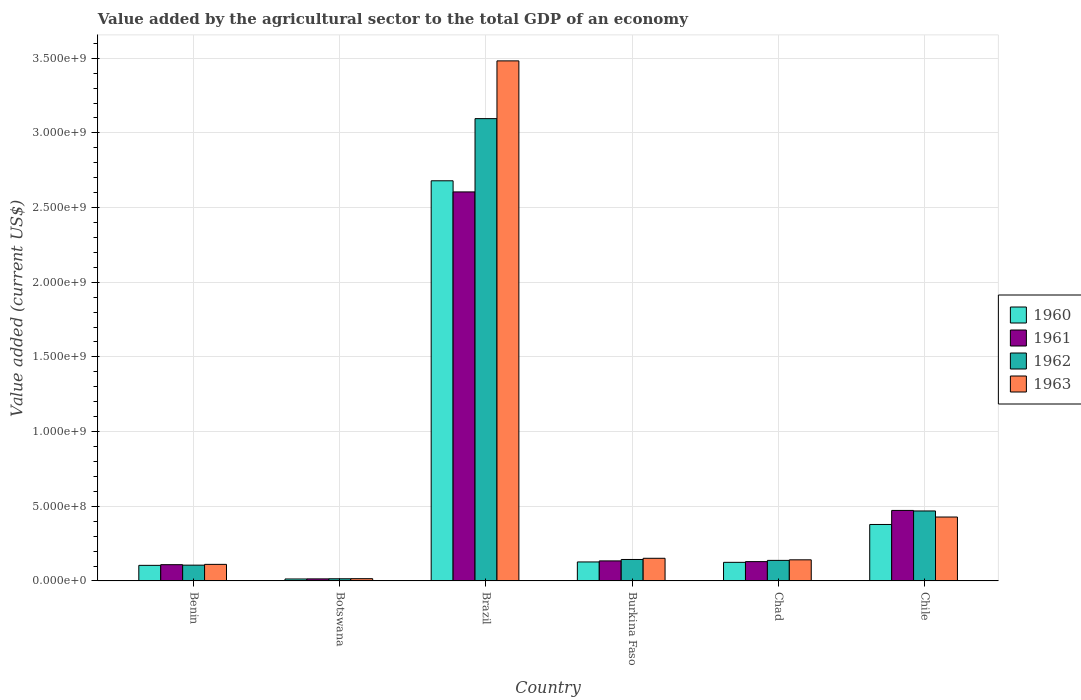How many groups of bars are there?
Keep it short and to the point. 6. How many bars are there on the 6th tick from the left?
Your response must be concise. 4. How many bars are there on the 1st tick from the right?
Your answer should be compact. 4. What is the label of the 1st group of bars from the left?
Your response must be concise. Benin. What is the value added by the agricultural sector to the total GDP in 1960 in Brazil?
Your response must be concise. 2.68e+09. Across all countries, what is the maximum value added by the agricultural sector to the total GDP in 1962?
Provide a succinct answer. 3.10e+09. Across all countries, what is the minimum value added by the agricultural sector to the total GDP in 1963?
Offer a terse response. 1.51e+07. In which country was the value added by the agricultural sector to the total GDP in 1961 maximum?
Give a very brief answer. Brazil. In which country was the value added by the agricultural sector to the total GDP in 1962 minimum?
Offer a very short reply. Botswana. What is the total value added by the agricultural sector to the total GDP in 1963 in the graph?
Keep it short and to the point. 4.33e+09. What is the difference between the value added by the agricultural sector to the total GDP in 1960 in Botswana and that in Chad?
Provide a succinct answer. -1.11e+08. What is the difference between the value added by the agricultural sector to the total GDP in 1961 in Benin and the value added by the agricultural sector to the total GDP in 1960 in Chad?
Offer a very short reply. -1.57e+07. What is the average value added by the agricultural sector to the total GDP in 1960 per country?
Your answer should be compact. 5.71e+08. What is the difference between the value added by the agricultural sector to the total GDP of/in 1960 and value added by the agricultural sector to the total GDP of/in 1962 in Burkina Faso?
Your response must be concise. -1.65e+07. In how many countries, is the value added by the agricultural sector to the total GDP in 1960 greater than 2100000000 US$?
Keep it short and to the point. 1. What is the ratio of the value added by the agricultural sector to the total GDP in 1960 in Benin to that in Botswana?
Make the answer very short. 7.94. Is the difference between the value added by the agricultural sector to the total GDP in 1960 in Botswana and Brazil greater than the difference between the value added by the agricultural sector to the total GDP in 1962 in Botswana and Brazil?
Keep it short and to the point. Yes. What is the difference between the highest and the second highest value added by the agricultural sector to the total GDP in 1960?
Offer a very short reply. -2.30e+09. What is the difference between the highest and the lowest value added by the agricultural sector to the total GDP in 1961?
Keep it short and to the point. 2.59e+09. In how many countries, is the value added by the agricultural sector to the total GDP in 1961 greater than the average value added by the agricultural sector to the total GDP in 1961 taken over all countries?
Your response must be concise. 1. Is it the case that in every country, the sum of the value added by the agricultural sector to the total GDP in 1961 and value added by the agricultural sector to the total GDP in 1960 is greater than the sum of value added by the agricultural sector to the total GDP in 1963 and value added by the agricultural sector to the total GDP in 1962?
Offer a terse response. No. What does the 3rd bar from the left in Chad represents?
Your response must be concise. 1962. Is it the case that in every country, the sum of the value added by the agricultural sector to the total GDP in 1962 and value added by the agricultural sector to the total GDP in 1960 is greater than the value added by the agricultural sector to the total GDP in 1961?
Keep it short and to the point. Yes. How many bars are there?
Make the answer very short. 24. Are all the bars in the graph horizontal?
Provide a succinct answer. No. How many countries are there in the graph?
Provide a succinct answer. 6. Are the values on the major ticks of Y-axis written in scientific E-notation?
Provide a short and direct response. Yes. Does the graph contain grids?
Ensure brevity in your answer.  Yes. How are the legend labels stacked?
Offer a very short reply. Vertical. What is the title of the graph?
Your answer should be compact. Value added by the agricultural sector to the total GDP of an economy. What is the label or title of the X-axis?
Your answer should be compact. Country. What is the label or title of the Y-axis?
Your response must be concise. Value added (current US$). What is the Value added (current US$) in 1960 in Benin?
Provide a succinct answer. 1.04e+08. What is the Value added (current US$) of 1961 in Benin?
Your response must be concise. 1.09e+08. What is the Value added (current US$) of 1962 in Benin?
Offer a very short reply. 1.06e+08. What is the Value added (current US$) in 1963 in Benin?
Provide a succinct answer. 1.11e+08. What is the Value added (current US$) in 1960 in Botswana?
Ensure brevity in your answer.  1.31e+07. What is the Value added (current US$) of 1961 in Botswana?
Your response must be concise. 1.38e+07. What is the Value added (current US$) of 1962 in Botswana?
Make the answer very short. 1.45e+07. What is the Value added (current US$) of 1963 in Botswana?
Make the answer very short. 1.51e+07. What is the Value added (current US$) of 1960 in Brazil?
Your answer should be very brief. 2.68e+09. What is the Value added (current US$) in 1961 in Brazil?
Make the answer very short. 2.60e+09. What is the Value added (current US$) in 1962 in Brazil?
Your response must be concise. 3.10e+09. What is the Value added (current US$) of 1963 in Brazil?
Offer a terse response. 3.48e+09. What is the Value added (current US$) in 1960 in Burkina Faso?
Ensure brevity in your answer.  1.27e+08. What is the Value added (current US$) of 1961 in Burkina Faso?
Give a very brief answer. 1.34e+08. What is the Value added (current US$) of 1962 in Burkina Faso?
Ensure brevity in your answer.  1.44e+08. What is the Value added (current US$) of 1963 in Burkina Faso?
Give a very brief answer. 1.52e+08. What is the Value added (current US$) in 1960 in Chad?
Make the answer very short. 1.25e+08. What is the Value added (current US$) in 1961 in Chad?
Provide a succinct answer. 1.29e+08. What is the Value added (current US$) in 1962 in Chad?
Ensure brevity in your answer.  1.38e+08. What is the Value added (current US$) of 1963 in Chad?
Your answer should be compact. 1.41e+08. What is the Value added (current US$) of 1960 in Chile?
Give a very brief answer. 3.78e+08. What is the Value added (current US$) in 1961 in Chile?
Offer a terse response. 4.72e+08. What is the Value added (current US$) of 1962 in Chile?
Make the answer very short. 4.69e+08. What is the Value added (current US$) in 1963 in Chile?
Your answer should be very brief. 4.28e+08. Across all countries, what is the maximum Value added (current US$) in 1960?
Give a very brief answer. 2.68e+09. Across all countries, what is the maximum Value added (current US$) in 1961?
Make the answer very short. 2.60e+09. Across all countries, what is the maximum Value added (current US$) in 1962?
Provide a short and direct response. 3.10e+09. Across all countries, what is the maximum Value added (current US$) in 1963?
Your answer should be compact. 3.48e+09. Across all countries, what is the minimum Value added (current US$) in 1960?
Make the answer very short. 1.31e+07. Across all countries, what is the minimum Value added (current US$) in 1961?
Keep it short and to the point. 1.38e+07. Across all countries, what is the minimum Value added (current US$) of 1962?
Your answer should be very brief. 1.45e+07. Across all countries, what is the minimum Value added (current US$) in 1963?
Keep it short and to the point. 1.51e+07. What is the total Value added (current US$) in 1960 in the graph?
Make the answer very short. 3.43e+09. What is the total Value added (current US$) in 1961 in the graph?
Give a very brief answer. 3.46e+09. What is the total Value added (current US$) in 1962 in the graph?
Offer a very short reply. 3.97e+09. What is the total Value added (current US$) in 1963 in the graph?
Make the answer very short. 4.33e+09. What is the difference between the Value added (current US$) in 1960 in Benin and that in Botswana?
Your answer should be very brief. 9.13e+07. What is the difference between the Value added (current US$) of 1961 in Benin and that in Botswana?
Give a very brief answer. 9.51e+07. What is the difference between the Value added (current US$) of 1962 in Benin and that in Botswana?
Give a very brief answer. 9.12e+07. What is the difference between the Value added (current US$) of 1963 in Benin and that in Botswana?
Your answer should be very brief. 9.59e+07. What is the difference between the Value added (current US$) in 1960 in Benin and that in Brazil?
Your answer should be very brief. -2.57e+09. What is the difference between the Value added (current US$) of 1961 in Benin and that in Brazil?
Keep it short and to the point. -2.50e+09. What is the difference between the Value added (current US$) of 1962 in Benin and that in Brazil?
Give a very brief answer. -2.99e+09. What is the difference between the Value added (current US$) of 1963 in Benin and that in Brazil?
Offer a very short reply. -3.37e+09. What is the difference between the Value added (current US$) of 1960 in Benin and that in Burkina Faso?
Your answer should be very brief. -2.28e+07. What is the difference between the Value added (current US$) in 1961 in Benin and that in Burkina Faso?
Your answer should be compact. -2.53e+07. What is the difference between the Value added (current US$) of 1962 in Benin and that in Burkina Faso?
Offer a very short reply. -3.80e+07. What is the difference between the Value added (current US$) in 1963 in Benin and that in Burkina Faso?
Provide a succinct answer. -4.07e+07. What is the difference between the Value added (current US$) of 1960 in Benin and that in Chad?
Make the answer very short. -2.02e+07. What is the difference between the Value added (current US$) in 1961 in Benin and that in Chad?
Offer a terse response. -2.05e+07. What is the difference between the Value added (current US$) in 1962 in Benin and that in Chad?
Ensure brevity in your answer.  -3.19e+07. What is the difference between the Value added (current US$) in 1963 in Benin and that in Chad?
Offer a terse response. -3.04e+07. What is the difference between the Value added (current US$) of 1960 in Benin and that in Chile?
Your response must be concise. -2.74e+08. What is the difference between the Value added (current US$) in 1961 in Benin and that in Chile?
Your response must be concise. -3.63e+08. What is the difference between the Value added (current US$) in 1962 in Benin and that in Chile?
Offer a terse response. -3.63e+08. What is the difference between the Value added (current US$) of 1963 in Benin and that in Chile?
Keep it short and to the point. -3.17e+08. What is the difference between the Value added (current US$) of 1960 in Botswana and that in Brazil?
Provide a short and direct response. -2.67e+09. What is the difference between the Value added (current US$) of 1961 in Botswana and that in Brazil?
Your response must be concise. -2.59e+09. What is the difference between the Value added (current US$) of 1962 in Botswana and that in Brazil?
Give a very brief answer. -3.08e+09. What is the difference between the Value added (current US$) in 1963 in Botswana and that in Brazil?
Offer a terse response. -3.47e+09. What is the difference between the Value added (current US$) of 1960 in Botswana and that in Burkina Faso?
Your answer should be very brief. -1.14e+08. What is the difference between the Value added (current US$) of 1961 in Botswana and that in Burkina Faso?
Make the answer very short. -1.20e+08. What is the difference between the Value added (current US$) of 1962 in Botswana and that in Burkina Faso?
Offer a terse response. -1.29e+08. What is the difference between the Value added (current US$) in 1963 in Botswana and that in Burkina Faso?
Ensure brevity in your answer.  -1.37e+08. What is the difference between the Value added (current US$) in 1960 in Botswana and that in Chad?
Ensure brevity in your answer.  -1.11e+08. What is the difference between the Value added (current US$) in 1961 in Botswana and that in Chad?
Keep it short and to the point. -1.16e+08. What is the difference between the Value added (current US$) in 1962 in Botswana and that in Chad?
Your answer should be compact. -1.23e+08. What is the difference between the Value added (current US$) in 1963 in Botswana and that in Chad?
Your answer should be compact. -1.26e+08. What is the difference between the Value added (current US$) of 1960 in Botswana and that in Chile?
Your answer should be very brief. -3.65e+08. What is the difference between the Value added (current US$) of 1961 in Botswana and that in Chile?
Provide a succinct answer. -4.58e+08. What is the difference between the Value added (current US$) of 1962 in Botswana and that in Chile?
Give a very brief answer. -4.54e+08. What is the difference between the Value added (current US$) in 1963 in Botswana and that in Chile?
Your response must be concise. -4.13e+08. What is the difference between the Value added (current US$) of 1960 in Brazil and that in Burkina Faso?
Your answer should be very brief. 2.55e+09. What is the difference between the Value added (current US$) in 1961 in Brazil and that in Burkina Faso?
Give a very brief answer. 2.47e+09. What is the difference between the Value added (current US$) in 1962 in Brazil and that in Burkina Faso?
Offer a very short reply. 2.95e+09. What is the difference between the Value added (current US$) of 1963 in Brazil and that in Burkina Faso?
Provide a succinct answer. 3.33e+09. What is the difference between the Value added (current US$) in 1960 in Brazil and that in Chad?
Ensure brevity in your answer.  2.55e+09. What is the difference between the Value added (current US$) of 1961 in Brazil and that in Chad?
Provide a succinct answer. 2.48e+09. What is the difference between the Value added (current US$) of 1962 in Brazil and that in Chad?
Your answer should be compact. 2.96e+09. What is the difference between the Value added (current US$) in 1963 in Brazil and that in Chad?
Provide a succinct answer. 3.34e+09. What is the difference between the Value added (current US$) of 1960 in Brazil and that in Chile?
Provide a short and direct response. 2.30e+09. What is the difference between the Value added (current US$) of 1961 in Brazil and that in Chile?
Provide a succinct answer. 2.13e+09. What is the difference between the Value added (current US$) of 1962 in Brazil and that in Chile?
Ensure brevity in your answer.  2.63e+09. What is the difference between the Value added (current US$) of 1963 in Brazil and that in Chile?
Your answer should be compact. 3.05e+09. What is the difference between the Value added (current US$) in 1960 in Burkina Faso and that in Chad?
Provide a short and direct response. 2.61e+06. What is the difference between the Value added (current US$) in 1961 in Burkina Faso and that in Chad?
Provide a short and direct response. 4.79e+06. What is the difference between the Value added (current US$) in 1962 in Burkina Faso and that in Chad?
Keep it short and to the point. 6.10e+06. What is the difference between the Value added (current US$) in 1963 in Burkina Faso and that in Chad?
Provide a short and direct response. 1.03e+07. What is the difference between the Value added (current US$) in 1960 in Burkina Faso and that in Chile?
Your answer should be compact. -2.51e+08. What is the difference between the Value added (current US$) of 1961 in Burkina Faso and that in Chile?
Keep it short and to the point. -3.38e+08. What is the difference between the Value added (current US$) in 1962 in Burkina Faso and that in Chile?
Keep it short and to the point. -3.25e+08. What is the difference between the Value added (current US$) of 1963 in Burkina Faso and that in Chile?
Provide a short and direct response. -2.76e+08. What is the difference between the Value added (current US$) in 1960 in Chad and that in Chile?
Offer a very short reply. -2.54e+08. What is the difference between the Value added (current US$) in 1961 in Chad and that in Chile?
Your answer should be compact. -3.43e+08. What is the difference between the Value added (current US$) of 1962 in Chad and that in Chile?
Offer a very short reply. -3.31e+08. What is the difference between the Value added (current US$) in 1963 in Chad and that in Chile?
Give a very brief answer. -2.87e+08. What is the difference between the Value added (current US$) in 1960 in Benin and the Value added (current US$) in 1961 in Botswana?
Ensure brevity in your answer.  9.06e+07. What is the difference between the Value added (current US$) of 1960 in Benin and the Value added (current US$) of 1962 in Botswana?
Your answer should be very brief. 8.99e+07. What is the difference between the Value added (current US$) of 1960 in Benin and the Value added (current US$) of 1963 in Botswana?
Offer a very short reply. 8.93e+07. What is the difference between the Value added (current US$) of 1961 in Benin and the Value added (current US$) of 1962 in Botswana?
Your response must be concise. 9.44e+07. What is the difference between the Value added (current US$) in 1961 in Benin and the Value added (current US$) in 1963 in Botswana?
Ensure brevity in your answer.  9.37e+07. What is the difference between the Value added (current US$) of 1962 in Benin and the Value added (current US$) of 1963 in Botswana?
Provide a succinct answer. 9.06e+07. What is the difference between the Value added (current US$) in 1960 in Benin and the Value added (current US$) in 1961 in Brazil?
Offer a terse response. -2.50e+09. What is the difference between the Value added (current US$) in 1960 in Benin and the Value added (current US$) in 1962 in Brazil?
Provide a short and direct response. -2.99e+09. What is the difference between the Value added (current US$) in 1960 in Benin and the Value added (current US$) in 1963 in Brazil?
Keep it short and to the point. -3.38e+09. What is the difference between the Value added (current US$) in 1961 in Benin and the Value added (current US$) in 1962 in Brazil?
Your answer should be compact. -2.99e+09. What is the difference between the Value added (current US$) of 1961 in Benin and the Value added (current US$) of 1963 in Brazil?
Provide a succinct answer. -3.37e+09. What is the difference between the Value added (current US$) of 1962 in Benin and the Value added (current US$) of 1963 in Brazil?
Offer a very short reply. -3.38e+09. What is the difference between the Value added (current US$) in 1960 in Benin and the Value added (current US$) in 1961 in Burkina Faso?
Make the answer very short. -2.98e+07. What is the difference between the Value added (current US$) in 1960 in Benin and the Value added (current US$) in 1962 in Burkina Faso?
Give a very brief answer. -3.93e+07. What is the difference between the Value added (current US$) in 1960 in Benin and the Value added (current US$) in 1963 in Burkina Faso?
Your answer should be very brief. -4.73e+07. What is the difference between the Value added (current US$) in 1961 in Benin and the Value added (current US$) in 1962 in Burkina Faso?
Offer a terse response. -3.48e+07. What is the difference between the Value added (current US$) in 1961 in Benin and the Value added (current US$) in 1963 in Burkina Faso?
Ensure brevity in your answer.  -4.28e+07. What is the difference between the Value added (current US$) in 1962 in Benin and the Value added (current US$) in 1963 in Burkina Faso?
Provide a short and direct response. -4.60e+07. What is the difference between the Value added (current US$) in 1960 in Benin and the Value added (current US$) in 1961 in Chad?
Provide a succinct answer. -2.50e+07. What is the difference between the Value added (current US$) of 1960 in Benin and the Value added (current US$) of 1962 in Chad?
Make the answer very short. -3.32e+07. What is the difference between the Value added (current US$) of 1960 in Benin and the Value added (current US$) of 1963 in Chad?
Your answer should be very brief. -3.70e+07. What is the difference between the Value added (current US$) of 1961 in Benin and the Value added (current US$) of 1962 in Chad?
Give a very brief answer. -2.87e+07. What is the difference between the Value added (current US$) of 1961 in Benin and the Value added (current US$) of 1963 in Chad?
Your answer should be very brief. -3.25e+07. What is the difference between the Value added (current US$) in 1962 in Benin and the Value added (current US$) in 1963 in Chad?
Ensure brevity in your answer.  -3.57e+07. What is the difference between the Value added (current US$) in 1960 in Benin and the Value added (current US$) in 1961 in Chile?
Make the answer very short. -3.68e+08. What is the difference between the Value added (current US$) of 1960 in Benin and the Value added (current US$) of 1962 in Chile?
Your answer should be very brief. -3.64e+08. What is the difference between the Value added (current US$) in 1960 in Benin and the Value added (current US$) in 1963 in Chile?
Your answer should be very brief. -3.24e+08. What is the difference between the Value added (current US$) of 1961 in Benin and the Value added (current US$) of 1962 in Chile?
Make the answer very short. -3.60e+08. What is the difference between the Value added (current US$) in 1961 in Benin and the Value added (current US$) in 1963 in Chile?
Provide a short and direct response. -3.19e+08. What is the difference between the Value added (current US$) in 1962 in Benin and the Value added (current US$) in 1963 in Chile?
Provide a succinct answer. -3.22e+08. What is the difference between the Value added (current US$) of 1960 in Botswana and the Value added (current US$) of 1961 in Brazil?
Make the answer very short. -2.59e+09. What is the difference between the Value added (current US$) in 1960 in Botswana and the Value added (current US$) in 1962 in Brazil?
Your response must be concise. -3.08e+09. What is the difference between the Value added (current US$) of 1960 in Botswana and the Value added (current US$) of 1963 in Brazil?
Offer a very short reply. -3.47e+09. What is the difference between the Value added (current US$) of 1961 in Botswana and the Value added (current US$) of 1962 in Brazil?
Provide a short and direct response. -3.08e+09. What is the difference between the Value added (current US$) in 1961 in Botswana and the Value added (current US$) in 1963 in Brazil?
Your answer should be very brief. -3.47e+09. What is the difference between the Value added (current US$) in 1962 in Botswana and the Value added (current US$) in 1963 in Brazil?
Offer a terse response. -3.47e+09. What is the difference between the Value added (current US$) in 1960 in Botswana and the Value added (current US$) in 1961 in Burkina Faso?
Provide a short and direct response. -1.21e+08. What is the difference between the Value added (current US$) in 1960 in Botswana and the Value added (current US$) in 1962 in Burkina Faso?
Keep it short and to the point. -1.31e+08. What is the difference between the Value added (current US$) of 1960 in Botswana and the Value added (current US$) of 1963 in Burkina Faso?
Ensure brevity in your answer.  -1.39e+08. What is the difference between the Value added (current US$) in 1961 in Botswana and the Value added (current US$) in 1962 in Burkina Faso?
Your response must be concise. -1.30e+08. What is the difference between the Value added (current US$) in 1961 in Botswana and the Value added (current US$) in 1963 in Burkina Faso?
Give a very brief answer. -1.38e+08. What is the difference between the Value added (current US$) in 1962 in Botswana and the Value added (current US$) in 1963 in Burkina Faso?
Your response must be concise. -1.37e+08. What is the difference between the Value added (current US$) in 1960 in Botswana and the Value added (current US$) in 1961 in Chad?
Offer a very short reply. -1.16e+08. What is the difference between the Value added (current US$) of 1960 in Botswana and the Value added (current US$) of 1962 in Chad?
Ensure brevity in your answer.  -1.24e+08. What is the difference between the Value added (current US$) in 1960 in Botswana and the Value added (current US$) in 1963 in Chad?
Make the answer very short. -1.28e+08. What is the difference between the Value added (current US$) in 1961 in Botswana and the Value added (current US$) in 1962 in Chad?
Make the answer very short. -1.24e+08. What is the difference between the Value added (current US$) of 1961 in Botswana and the Value added (current US$) of 1963 in Chad?
Ensure brevity in your answer.  -1.28e+08. What is the difference between the Value added (current US$) of 1962 in Botswana and the Value added (current US$) of 1963 in Chad?
Keep it short and to the point. -1.27e+08. What is the difference between the Value added (current US$) in 1960 in Botswana and the Value added (current US$) in 1961 in Chile?
Give a very brief answer. -4.59e+08. What is the difference between the Value added (current US$) of 1960 in Botswana and the Value added (current US$) of 1962 in Chile?
Ensure brevity in your answer.  -4.55e+08. What is the difference between the Value added (current US$) in 1960 in Botswana and the Value added (current US$) in 1963 in Chile?
Make the answer very short. -4.15e+08. What is the difference between the Value added (current US$) of 1961 in Botswana and the Value added (current US$) of 1962 in Chile?
Offer a terse response. -4.55e+08. What is the difference between the Value added (current US$) in 1961 in Botswana and the Value added (current US$) in 1963 in Chile?
Offer a very short reply. -4.14e+08. What is the difference between the Value added (current US$) of 1962 in Botswana and the Value added (current US$) of 1963 in Chile?
Ensure brevity in your answer.  -4.13e+08. What is the difference between the Value added (current US$) of 1960 in Brazil and the Value added (current US$) of 1961 in Burkina Faso?
Ensure brevity in your answer.  2.55e+09. What is the difference between the Value added (current US$) in 1960 in Brazil and the Value added (current US$) in 1962 in Burkina Faso?
Keep it short and to the point. 2.54e+09. What is the difference between the Value added (current US$) of 1960 in Brazil and the Value added (current US$) of 1963 in Burkina Faso?
Your answer should be very brief. 2.53e+09. What is the difference between the Value added (current US$) in 1961 in Brazil and the Value added (current US$) in 1962 in Burkina Faso?
Your answer should be very brief. 2.46e+09. What is the difference between the Value added (current US$) in 1961 in Brazil and the Value added (current US$) in 1963 in Burkina Faso?
Offer a terse response. 2.45e+09. What is the difference between the Value added (current US$) in 1962 in Brazil and the Value added (current US$) in 1963 in Burkina Faso?
Offer a terse response. 2.94e+09. What is the difference between the Value added (current US$) in 1960 in Brazil and the Value added (current US$) in 1961 in Chad?
Offer a very short reply. 2.55e+09. What is the difference between the Value added (current US$) of 1960 in Brazil and the Value added (current US$) of 1962 in Chad?
Ensure brevity in your answer.  2.54e+09. What is the difference between the Value added (current US$) in 1960 in Brazil and the Value added (current US$) in 1963 in Chad?
Provide a succinct answer. 2.54e+09. What is the difference between the Value added (current US$) of 1961 in Brazil and the Value added (current US$) of 1962 in Chad?
Your response must be concise. 2.47e+09. What is the difference between the Value added (current US$) in 1961 in Brazil and the Value added (current US$) in 1963 in Chad?
Your answer should be very brief. 2.46e+09. What is the difference between the Value added (current US$) in 1962 in Brazil and the Value added (current US$) in 1963 in Chad?
Ensure brevity in your answer.  2.95e+09. What is the difference between the Value added (current US$) of 1960 in Brazil and the Value added (current US$) of 1961 in Chile?
Keep it short and to the point. 2.21e+09. What is the difference between the Value added (current US$) in 1960 in Brazil and the Value added (current US$) in 1962 in Chile?
Your answer should be compact. 2.21e+09. What is the difference between the Value added (current US$) in 1960 in Brazil and the Value added (current US$) in 1963 in Chile?
Provide a short and direct response. 2.25e+09. What is the difference between the Value added (current US$) in 1961 in Brazil and the Value added (current US$) in 1962 in Chile?
Offer a very short reply. 2.14e+09. What is the difference between the Value added (current US$) in 1961 in Brazil and the Value added (current US$) in 1963 in Chile?
Give a very brief answer. 2.18e+09. What is the difference between the Value added (current US$) in 1962 in Brazil and the Value added (current US$) in 1963 in Chile?
Ensure brevity in your answer.  2.67e+09. What is the difference between the Value added (current US$) of 1960 in Burkina Faso and the Value added (current US$) of 1961 in Chad?
Make the answer very short. -2.21e+06. What is the difference between the Value added (current US$) of 1960 in Burkina Faso and the Value added (current US$) of 1962 in Chad?
Your answer should be very brief. -1.04e+07. What is the difference between the Value added (current US$) of 1960 in Burkina Faso and the Value added (current US$) of 1963 in Chad?
Provide a succinct answer. -1.42e+07. What is the difference between the Value added (current US$) in 1961 in Burkina Faso and the Value added (current US$) in 1962 in Chad?
Offer a very short reply. -3.43e+06. What is the difference between the Value added (current US$) in 1961 in Burkina Faso and the Value added (current US$) in 1963 in Chad?
Ensure brevity in your answer.  -7.20e+06. What is the difference between the Value added (current US$) of 1962 in Burkina Faso and the Value added (current US$) of 1963 in Chad?
Your answer should be compact. 2.33e+06. What is the difference between the Value added (current US$) in 1960 in Burkina Faso and the Value added (current US$) in 1961 in Chile?
Your answer should be compact. -3.45e+08. What is the difference between the Value added (current US$) in 1960 in Burkina Faso and the Value added (current US$) in 1962 in Chile?
Give a very brief answer. -3.41e+08. What is the difference between the Value added (current US$) of 1960 in Burkina Faso and the Value added (current US$) of 1963 in Chile?
Your answer should be compact. -3.01e+08. What is the difference between the Value added (current US$) in 1961 in Burkina Faso and the Value added (current US$) in 1962 in Chile?
Your answer should be compact. -3.34e+08. What is the difference between the Value added (current US$) of 1961 in Burkina Faso and the Value added (current US$) of 1963 in Chile?
Give a very brief answer. -2.94e+08. What is the difference between the Value added (current US$) in 1962 in Burkina Faso and the Value added (current US$) in 1963 in Chile?
Make the answer very short. -2.84e+08. What is the difference between the Value added (current US$) in 1960 in Chad and the Value added (current US$) in 1961 in Chile?
Ensure brevity in your answer.  -3.48e+08. What is the difference between the Value added (current US$) in 1960 in Chad and the Value added (current US$) in 1962 in Chile?
Provide a short and direct response. -3.44e+08. What is the difference between the Value added (current US$) of 1960 in Chad and the Value added (current US$) of 1963 in Chile?
Offer a very short reply. -3.03e+08. What is the difference between the Value added (current US$) of 1961 in Chad and the Value added (current US$) of 1962 in Chile?
Your answer should be compact. -3.39e+08. What is the difference between the Value added (current US$) in 1961 in Chad and the Value added (current US$) in 1963 in Chile?
Offer a terse response. -2.99e+08. What is the difference between the Value added (current US$) of 1962 in Chad and the Value added (current US$) of 1963 in Chile?
Your response must be concise. -2.90e+08. What is the average Value added (current US$) in 1960 per country?
Offer a very short reply. 5.71e+08. What is the average Value added (current US$) in 1961 per country?
Give a very brief answer. 5.77e+08. What is the average Value added (current US$) of 1962 per country?
Provide a succinct answer. 6.61e+08. What is the average Value added (current US$) in 1963 per country?
Your answer should be compact. 7.22e+08. What is the difference between the Value added (current US$) of 1960 and Value added (current US$) of 1961 in Benin?
Give a very brief answer. -4.46e+06. What is the difference between the Value added (current US$) in 1960 and Value added (current US$) in 1962 in Benin?
Your answer should be compact. -1.30e+06. What is the difference between the Value added (current US$) in 1960 and Value added (current US$) in 1963 in Benin?
Offer a very short reply. -6.61e+06. What is the difference between the Value added (current US$) in 1961 and Value added (current US$) in 1962 in Benin?
Provide a succinct answer. 3.16e+06. What is the difference between the Value added (current US$) of 1961 and Value added (current US$) of 1963 in Benin?
Offer a very short reply. -2.15e+06. What is the difference between the Value added (current US$) of 1962 and Value added (current US$) of 1963 in Benin?
Offer a terse response. -5.30e+06. What is the difference between the Value added (current US$) of 1960 and Value added (current US$) of 1961 in Botswana?
Keep it short and to the point. -6.50e+05. What is the difference between the Value added (current US$) in 1960 and Value added (current US$) in 1962 in Botswana?
Offer a terse response. -1.35e+06. What is the difference between the Value added (current US$) of 1960 and Value added (current US$) of 1963 in Botswana?
Provide a short and direct response. -1.99e+06. What is the difference between the Value added (current US$) of 1961 and Value added (current US$) of 1962 in Botswana?
Provide a succinct answer. -7.04e+05. What is the difference between the Value added (current US$) of 1961 and Value added (current US$) of 1963 in Botswana?
Offer a terse response. -1.34e+06. What is the difference between the Value added (current US$) in 1962 and Value added (current US$) in 1963 in Botswana?
Ensure brevity in your answer.  -6.34e+05. What is the difference between the Value added (current US$) of 1960 and Value added (current US$) of 1961 in Brazil?
Keep it short and to the point. 7.45e+07. What is the difference between the Value added (current US$) of 1960 and Value added (current US$) of 1962 in Brazil?
Your answer should be very brief. -4.16e+08. What is the difference between the Value added (current US$) of 1960 and Value added (current US$) of 1963 in Brazil?
Offer a terse response. -8.03e+08. What is the difference between the Value added (current US$) of 1961 and Value added (current US$) of 1962 in Brazil?
Keep it short and to the point. -4.91e+08. What is the difference between the Value added (current US$) of 1961 and Value added (current US$) of 1963 in Brazil?
Offer a very short reply. -8.77e+08. What is the difference between the Value added (current US$) of 1962 and Value added (current US$) of 1963 in Brazil?
Offer a terse response. -3.87e+08. What is the difference between the Value added (current US$) in 1960 and Value added (current US$) in 1961 in Burkina Faso?
Give a very brief answer. -7.00e+06. What is the difference between the Value added (current US$) of 1960 and Value added (current US$) of 1962 in Burkina Faso?
Give a very brief answer. -1.65e+07. What is the difference between the Value added (current US$) in 1960 and Value added (current US$) in 1963 in Burkina Faso?
Give a very brief answer. -2.45e+07. What is the difference between the Value added (current US$) of 1961 and Value added (current US$) of 1962 in Burkina Faso?
Your response must be concise. -9.53e+06. What is the difference between the Value added (current US$) in 1961 and Value added (current US$) in 1963 in Burkina Faso?
Your answer should be compact. -1.75e+07. What is the difference between the Value added (current US$) in 1962 and Value added (current US$) in 1963 in Burkina Faso?
Offer a very short reply. -7.98e+06. What is the difference between the Value added (current US$) in 1960 and Value added (current US$) in 1961 in Chad?
Offer a terse response. -4.82e+06. What is the difference between the Value added (current US$) in 1960 and Value added (current US$) in 1962 in Chad?
Make the answer very short. -1.30e+07. What is the difference between the Value added (current US$) in 1960 and Value added (current US$) in 1963 in Chad?
Make the answer very short. -1.68e+07. What is the difference between the Value added (current US$) in 1961 and Value added (current US$) in 1962 in Chad?
Provide a succinct answer. -8.22e+06. What is the difference between the Value added (current US$) in 1961 and Value added (current US$) in 1963 in Chad?
Make the answer very short. -1.20e+07. What is the difference between the Value added (current US$) in 1962 and Value added (current US$) in 1963 in Chad?
Provide a succinct answer. -3.78e+06. What is the difference between the Value added (current US$) of 1960 and Value added (current US$) of 1961 in Chile?
Provide a succinct answer. -9.41e+07. What is the difference between the Value added (current US$) in 1960 and Value added (current US$) in 1962 in Chile?
Your answer should be compact. -9.05e+07. What is the difference between the Value added (current US$) of 1960 and Value added (current US$) of 1963 in Chile?
Your response must be concise. -4.98e+07. What is the difference between the Value added (current US$) in 1961 and Value added (current US$) in 1962 in Chile?
Offer a very short reply. 3.57e+06. What is the difference between the Value added (current US$) in 1961 and Value added (current US$) in 1963 in Chile?
Ensure brevity in your answer.  4.42e+07. What is the difference between the Value added (current US$) in 1962 and Value added (current US$) in 1963 in Chile?
Provide a succinct answer. 4.07e+07. What is the ratio of the Value added (current US$) in 1960 in Benin to that in Botswana?
Your response must be concise. 7.94. What is the ratio of the Value added (current US$) in 1961 in Benin to that in Botswana?
Make the answer very short. 7.89. What is the ratio of the Value added (current US$) in 1962 in Benin to that in Botswana?
Offer a very short reply. 7.29. What is the ratio of the Value added (current US$) in 1963 in Benin to that in Botswana?
Offer a very short reply. 7.34. What is the ratio of the Value added (current US$) in 1960 in Benin to that in Brazil?
Offer a very short reply. 0.04. What is the ratio of the Value added (current US$) of 1961 in Benin to that in Brazil?
Provide a short and direct response. 0.04. What is the ratio of the Value added (current US$) in 1962 in Benin to that in Brazil?
Make the answer very short. 0.03. What is the ratio of the Value added (current US$) of 1963 in Benin to that in Brazil?
Keep it short and to the point. 0.03. What is the ratio of the Value added (current US$) in 1960 in Benin to that in Burkina Faso?
Provide a succinct answer. 0.82. What is the ratio of the Value added (current US$) of 1961 in Benin to that in Burkina Faso?
Make the answer very short. 0.81. What is the ratio of the Value added (current US$) of 1962 in Benin to that in Burkina Faso?
Offer a terse response. 0.74. What is the ratio of the Value added (current US$) in 1963 in Benin to that in Burkina Faso?
Ensure brevity in your answer.  0.73. What is the ratio of the Value added (current US$) of 1960 in Benin to that in Chad?
Your answer should be compact. 0.84. What is the ratio of the Value added (current US$) of 1961 in Benin to that in Chad?
Offer a terse response. 0.84. What is the ratio of the Value added (current US$) in 1962 in Benin to that in Chad?
Provide a short and direct response. 0.77. What is the ratio of the Value added (current US$) of 1963 in Benin to that in Chad?
Provide a succinct answer. 0.79. What is the ratio of the Value added (current US$) of 1960 in Benin to that in Chile?
Provide a short and direct response. 0.28. What is the ratio of the Value added (current US$) in 1961 in Benin to that in Chile?
Offer a terse response. 0.23. What is the ratio of the Value added (current US$) of 1962 in Benin to that in Chile?
Your answer should be compact. 0.23. What is the ratio of the Value added (current US$) of 1963 in Benin to that in Chile?
Give a very brief answer. 0.26. What is the ratio of the Value added (current US$) in 1960 in Botswana to that in Brazil?
Provide a succinct answer. 0. What is the ratio of the Value added (current US$) in 1961 in Botswana to that in Brazil?
Your answer should be compact. 0.01. What is the ratio of the Value added (current US$) of 1962 in Botswana to that in Brazil?
Provide a short and direct response. 0. What is the ratio of the Value added (current US$) in 1963 in Botswana to that in Brazil?
Provide a succinct answer. 0. What is the ratio of the Value added (current US$) in 1960 in Botswana to that in Burkina Faso?
Offer a terse response. 0.1. What is the ratio of the Value added (current US$) of 1961 in Botswana to that in Burkina Faso?
Your answer should be very brief. 0.1. What is the ratio of the Value added (current US$) in 1962 in Botswana to that in Burkina Faso?
Keep it short and to the point. 0.1. What is the ratio of the Value added (current US$) of 1963 in Botswana to that in Burkina Faso?
Make the answer very short. 0.1. What is the ratio of the Value added (current US$) of 1960 in Botswana to that in Chad?
Provide a short and direct response. 0.11. What is the ratio of the Value added (current US$) of 1961 in Botswana to that in Chad?
Ensure brevity in your answer.  0.11. What is the ratio of the Value added (current US$) in 1962 in Botswana to that in Chad?
Offer a terse response. 0.11. What is the ratio of the Value added (current US$) of 1963 in Botswana to that in Chad?
Ensure brevity in your answer.  0.11. What is the ratio of the Value added (current US$) of 1960 in Botswana to that in Chile?
Offer a very short reply. 0.03. What is the ratio of the Value added (current US$) in 1961 in Botswana to that in Chile?
Your response must be concise. 0.03. What is the ratio of the Value added (current US$) in 1962 in Botswana to that in Chile?
Ensure brevity in your answer.  0.03. What is the ratio of the Value added (current US$) of 1963 in Botswana to that in Chile?
Keep it short and to the point. 0.04. What is the ratio of the Value added (current US$) in 1960 in Brazil to that in Burkina Faso?
Keep it short and to the point. 21.07. What is the ratio of the Value added (current US$) of 1961 in Brazil to that in Burkina Faso?
Offer a very short reply. 19.41. What is the ratio of the Value added (current US$) of 1962 in Brazil to that in Burkina Faso?
Your answer should be compact. 21.54. What is the ratio of the Value added (current US$) of 1963 in Brazil to that in Burkina Faso?
Your answer should be very brief. 22.96. What is the ratio of the Value added (current US$) in 1960 in Brazil to that in Chad?
Provide a short and direct response. 21.51. What is the ratio of the Value added (current US$) of 1961 in Brazil to that in Chad?
Offer a terse response. 20.13. What is the ratio of the Value added (current US$) of 1962 in Brazil to that in Chad?
Provide a succinct answer. 22.5. What is the ratio of the Value added (current US$) in 1963 in Brazil to that in Chad?
Make the answer very short. 24.63. What is the ratio of the Value added (current US$) of 1960 in Brazil to that in Chile?
Your response must be concise. 7.09. What is the ratio of the Value added (current US$) of 1961 in Brazil to that in Chile?
Offer a very short reply. 5.52. What is the ratio of the Value added (current US$) in 1962 in Brazil to that in Chile?
Make the answer very short. 6.61. What is the ratio of the Value added (current US$) of 1963 in Brazil to that in Chile?
Give a very brief answer. 8.14. What is the ratio of the Value added (current US$) of 1961 in Burkina Faso to that in Chad?
Keep it short and to the point. 1.04. What is the ratio of the Value added (current US$) of 1962 in Burkina Faso to that in Chad?
Ensure brevity in your answer.  1.04. What is the ratio of the Value added (current US$) of 1963 in Burkina Faso to that in Chad?
Offer a terse response. 1.07. What is the ratio of the Value added (current US$) of 1960 in Burkina Faso to that in Chile?
Offer a very short reply. 0.34. What is the ratio of the Value added (current US$) in 1961 in Burkina Faso to that in Chile?
Provide a succinct answer. 0.28. What is the ratio of the Value added (current US$) in 1962 in Burkina Faso to that in Chile?
Make the answer very short. 0.31. What is the ratio of the Value added (current US$) in 1963 in Burkina Faso to that in Chile?
Give a very brief answer. 0.35. What is the ratio of the Value added (current US$) of 1960 in Chad to that in Chile?
Make the answer very short. 0.33. What is the ratio of the Value added (current US$) of 1961 in Chad to that in Chile?
Your answer should be compact. 0.27. What is the ratio of the Value added (current US$) in 1962 in Chad to that in Chile?
Offer a very short reply. 0.29. What is the ratio of the Value added (current US$) of 1963 in Chad to that in Chile?
Make the answer very short. 0.33. What is the difference between the highest and the second highest Value added (current US$) in 1960?
Offer a very short reply. 2.30e+09. What is the difference between the highest and the second highest Value added (current US$) of 1961?
Offer a very short reply. 2.13e+09. What is the difference between the highest and the second highest Value added (current US$) in 1962?
Give a very brief answer. 2.63e+09. What is the difference between the highest and the second highest Value added (current US$) in 1963?
Provide a short and direct response. 3.05e+09. What is the difference between the highest and the lowest Value added (current US$) in 1960?
Provide a succinct answer. 2.67e+09. What is the difference between the highest and the lowest Value added (current US$) of 1961?
Provide a succinct answer. 2.59e+09. What is the difference between the highest and the lowest Value added (current US$) of 1962?
Your answer should be very brief. 3.08e+09. What is the difference between the highest and the lowest Value added (current US$) in 1963?
Your response must be concise. 3.47e+09. 